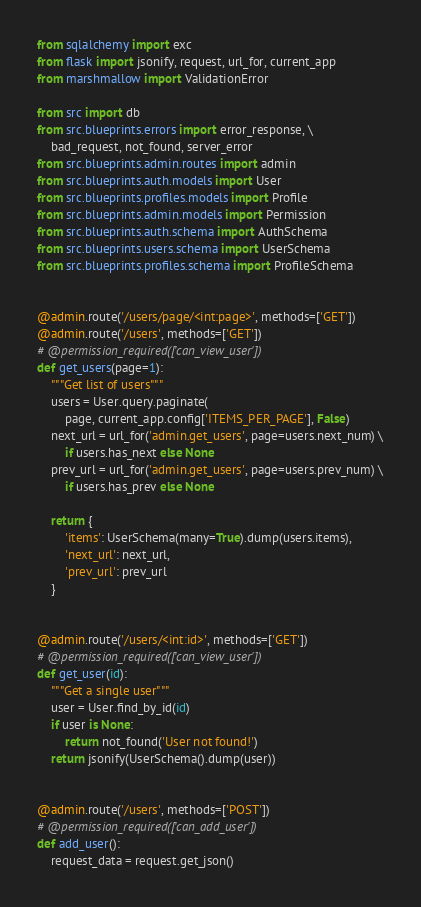Convert code to text. <code><loc_0><loc_0><loc_500><loc_500><_Python_>from sqlalchemy import exc
from flask import jsonify, request, url_for, current_app
from marshmallow import ValidationError

from src import db
from src.blueprints.errors import error_response, \
    bad_request, not_found, server_error
from src.blueprints.admin.routes import admin
from src.blueprints.auth.models import User
from src.blueprints.profiles.models import Profile
from src.blueprints.admin.models import Permission
from src.blueprints.auth.schema import AuthSchema
from src.blueprints.users.schema import UserSchema
from src.blueprints.profiles.schema import ProfileSchema


@admin.route('/users/page/<int:page>', methods=['GET'])
@admin.route('/users', methods=['GET'])
# @permission_required(['can_view_user'])
def get_users(page=1):
    """Get list of users"""
    users = User.query.paginate(
        page, current_app.config['ITEMS_PER_PAGE'], False)
    next_url = url_for('admin.get_users', page=users.next_num) \
        if users.has_next else None
    prev_url = url_for('admin.get_users', page=users.prev_num) \
        if users.has_prev else None

    return {
        'items': UserSchema(many=True).dump(users.items),
        'next_url': next_url,
        'prev_url': prev_url
    }


@admin.route('/users/<int:id>', methods=['GET'])
# @permission_required(['can_view_user'])
def get_user(id):
    """Get a single user"""
    user = User.find_by_id(id)
    if user is None:
        return not_found('User not found!')
    return jsonify(UserSchema().dump(user))


@admin.route('/users', methods=['POST'])
# @permission_required(['can_add_user'])
def add_user():
    request_data = request.get_json()
</code> 